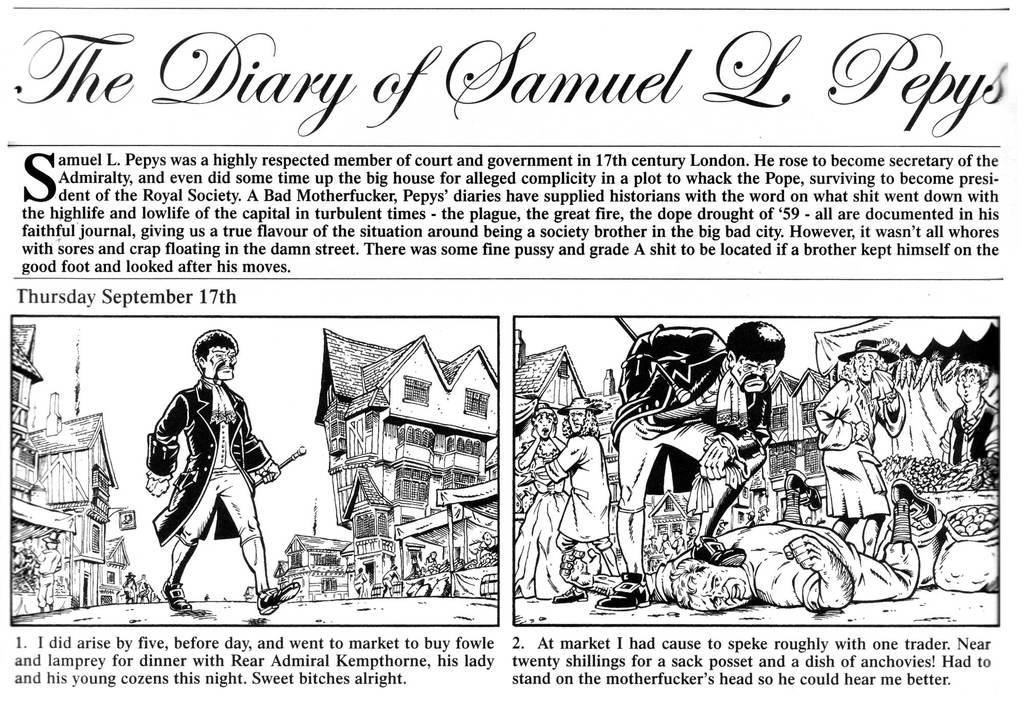What is the main object in the image? There is a newspaper in the image. What type of content can be found on the newspaper? The newspaper contains cartoon pictures. Is there any text on the newspaper? Yes, there is text on the newspaper. What type of rake is shown in the cartoon picture on the newspaper? There is no rake present in the image, as the provided facts only mention the presence of a newspaper with cartoon pictures. 